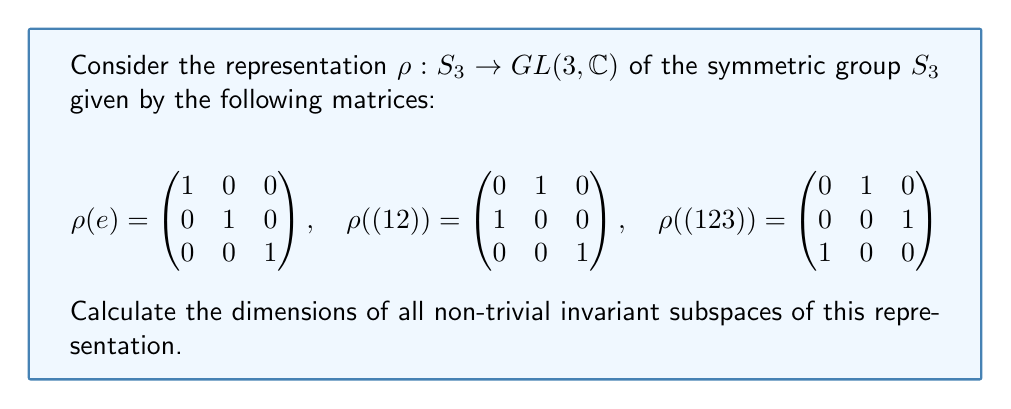Provide a solution to this math problem. To find the dimensions of invariant subspaces, we'll follow these steps:

1) First, we need to find the character of the representation. The character $\chi$ is given by the trace of each matrix:

   $\chi(e) = 3$
   $\chi((12)) = 1$
   $\chi((123)) = 0$

2) Now, we decompose this representation into irreducible representations. For $S_3$, there are three irreducible representations: the trivial representation (1-dimensional), the sign representation (1-dimensional), and the standard representation (2-dimensional).

3) Let's call $a$, $b$, and $c$ the number of times each irreducible representation appears in our representation. We can set up a system of equations based on the character values:

   $a + b + 2c = 3$  (dimension equation)
   $a - b = 1$       (character value for (12))
   $a + b - c = 0$   (character value for (123))

4) Solving this system, we get $a = 1$, $b = 0$, $c = 1$

5) This means our representation decomposes as:
   $\rho = 1 \cdot \text{trivial} \oplus 1 \cdot \text{standard}$

6) The trivial representation gives us a 1-dimensional invariant subspace, and the standard representation gives us a 2-dimensional invariant subspace.

Therefore, the non-trivial invariant subspaces have dimensions 1 and 2.
Answer: 1, 2 